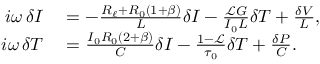Convert formula to latex. <formula><loc_0><loc_0><loc_500><loc_500>\begin{array} { r l } { i \omega \delta I } & = - \frac { R _ { \ell } + R _ { 0 } ( 1 + \beta ) } { L } \delta I - \frac { \ m a t h s c r { L } G } { I _ { 0 } L } \delta T + \frac { \delta V } { L } , } \\ { i \omega \delta T } & = \frac { I _ { 0 } R _ { 0 } ( 2 + \beta ) } { C } \delta I - \frac { 1 - \ m a t h s c r { L } } { \tau _ { 0 } } \delta T + \frac { \delta P } { C } . } \end{array}</formula> 